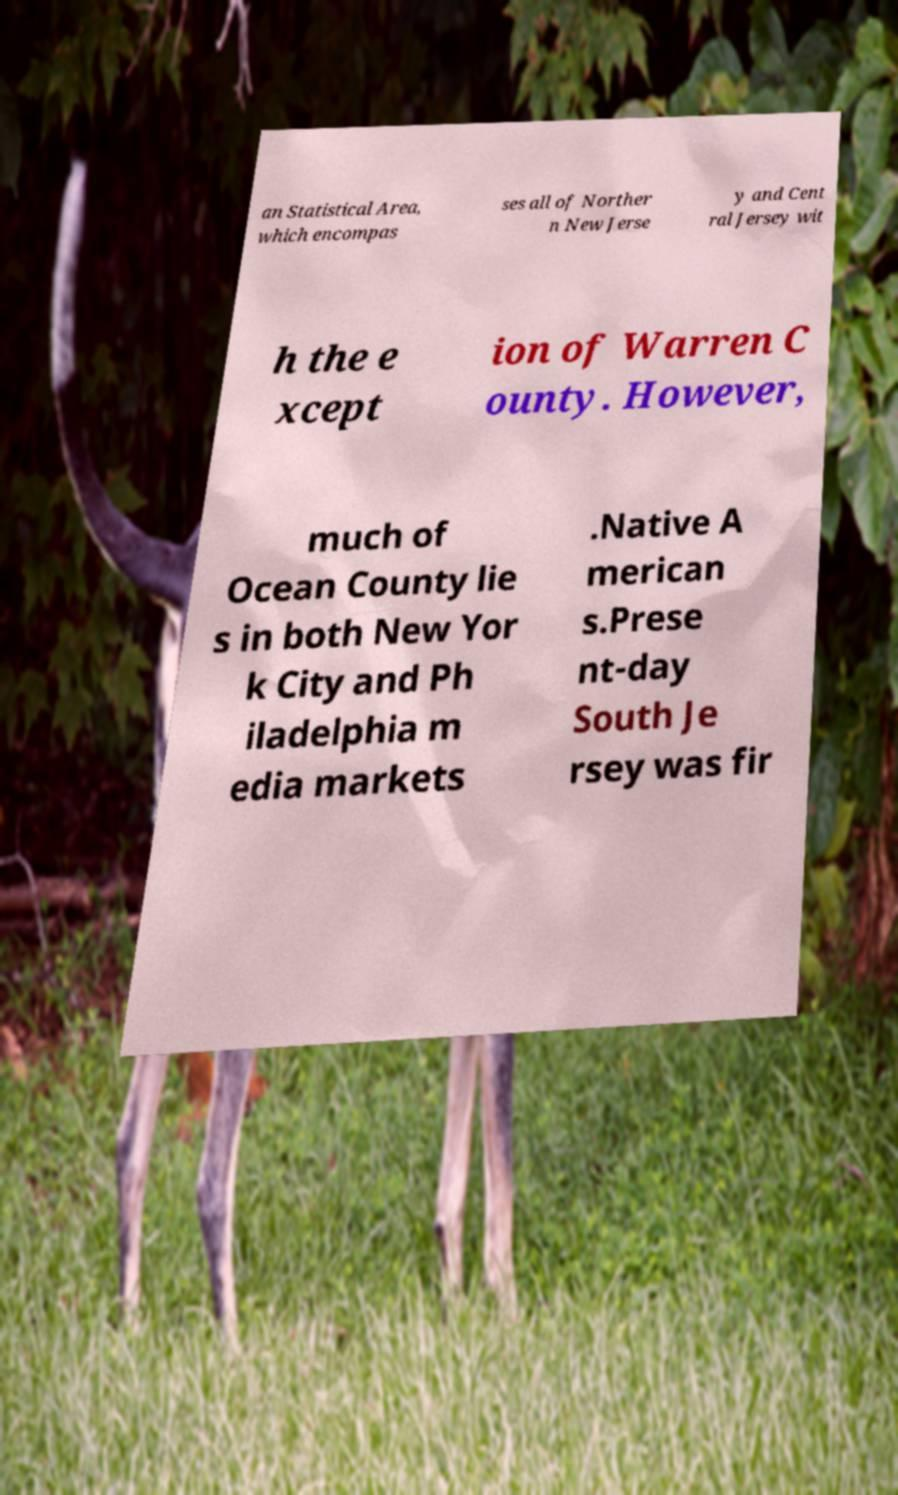There's text embedded in this image that I need extracted. Can you transcribe it verbatim? an Statistical Area, which encompas ses all of Norther n New Jerse y and Cent ral Jersey wit h the e xcept ion of Warren C ounty. However, much of Ocean County lie s in both New Yor k City and Ph iladelphia m edia markets .Native A merican s.Prese nt-day South Je rsey was fir 